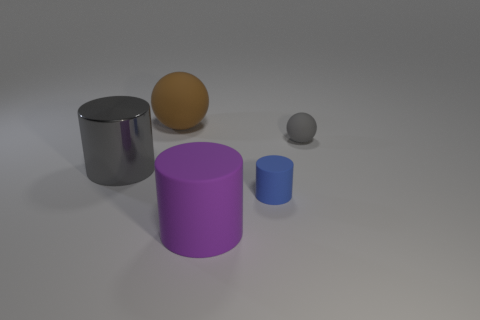Add 3 rubber things. How many objects exist? 8 Subtract all spheres. How many objects are left? 3 Add 3 large brown rubber spheres. How many large brown rubber spheres exist? 4 Subtract 0 brown cubes. How many objects are left? 5 Subtract all big gray metal cylinders. Subtract all small rubber spheres. How many objects are left? 3 Add 4 small blue things. How many small blue things are left? 5 